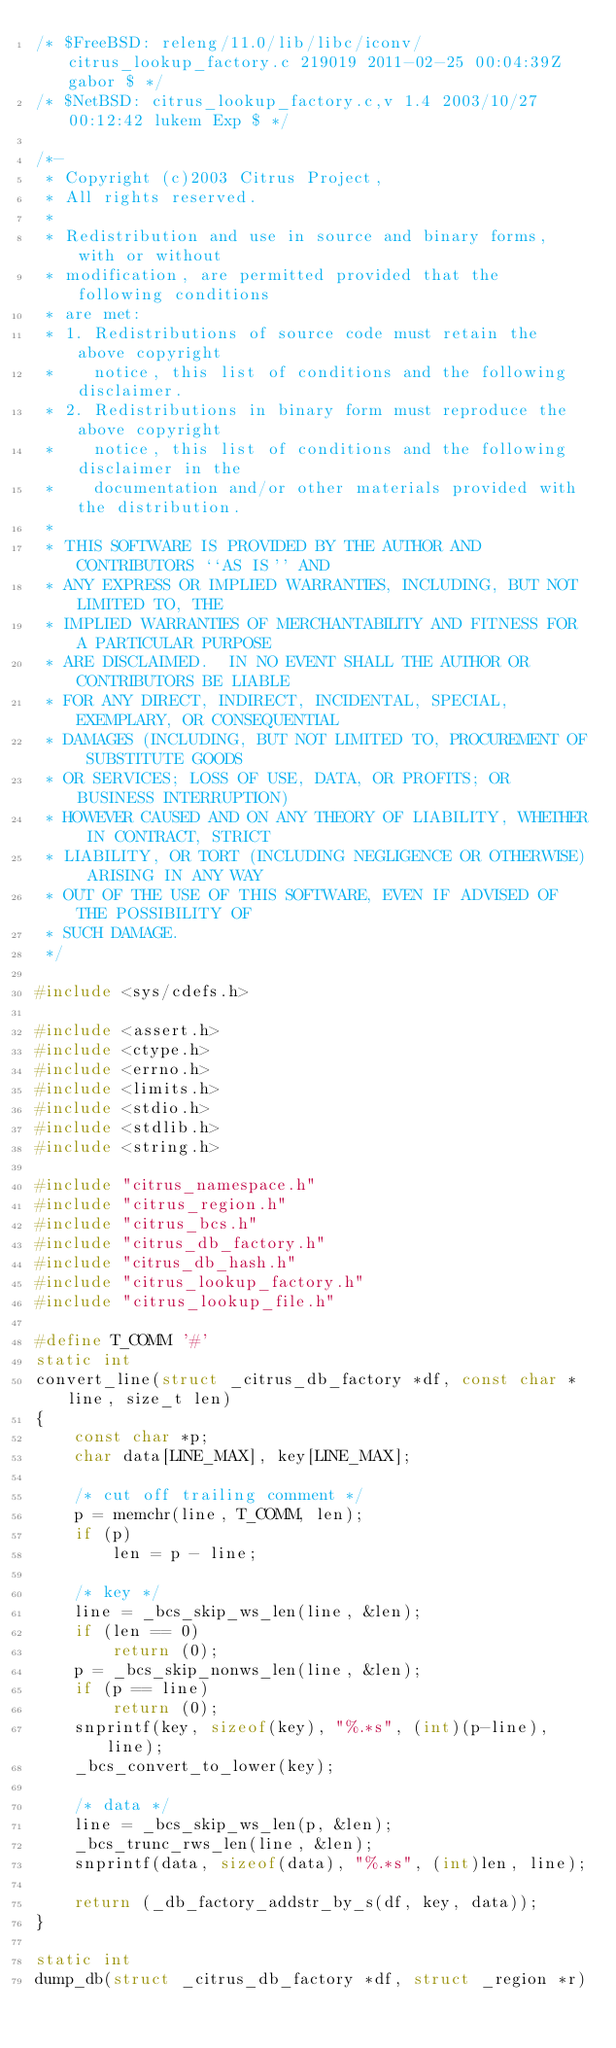Convert code to text. <code><loc_0><loc_0><loc_500><loc_500><_C_>/* $FreeBSD: releng/11.0/lib/libc/iconv/citrus_lookup_factory.c 219019 2011-02-25 00:04:39Z gabor $ */
/* $NetBSD: citrus_lookup_factory.c,v 1.4 2003/10/27 00:12:42 lukem Exp $ */

/*-
 * Copyright (c)2003 Citrus Project,
 * All rights reserved.
 *
 * Redistribution and use in source and binary forms, with or without
 * modification, are permitted provided that the following conditions
 * are met:
 * 1. Redistributions of source code must retain the above copyright
 *    notice, this list of conditions and the following disclaimer.
 * 2. Redistributions in binary form must reproduce the above copyright
 *    notice, this list of conditions and the following disclaimer in the
 *    documentation and/or other materials provided with the distribution.
 *
 * THIS SOFTWARE IS PROVIDED BY THE AUTHOR AND CONTRIBUTORS ``AS IS'' AND
 * ANY EXPRESS OR IMPLIED WARRANTIES, INCLUDING, BUT NOT LIMITED TO, THE
 * IMPLIED WARRANTIES OF MERCHANTABILITY AND FITNESS FOR A PARTICULAR PURPOSE
 * ARE DISCLAIMED.  IN NO EVENT SHALL THE AUTHOR OR CONTRIBUTORS BE LIABLE
 * FOR ANY DIRECT, INDIRECT, INCIDENTAL, SPECIAL, EXEMPLARY, OR CONSEQUENTIAL
 * DAMAGES (INCLUDING, BUT NOT LIMITED TO, PROCUREMENT OF SUBSTITUTE GOODS
 * OR SERVICES; LOSS OF USE, DATA, OR PROFITS; OR BUSINESS INTERRUPTION)
 * HOWEVER CAUSED AND ON ANY THEORY OF LIABILITY, WHETHER IN CONTRACT, STRICT
 * LIABILITY, OR TORT (INCLUDING NEGLIGENCE OR OTHERWISE) ARISING IN ANY WAY
 * OUT OF THE USE OF THIS SOFTWARE, EVEN IF ADVISED OF THE POSSIBILITY OF
 * SUCH DAMAGE.
 */

#include <sys/cdefs.h>

#include <assert.h>
#include <ctype.h>
#include <errno.h>
#include <limits.h>
#include <stdio.h>
#include <stdlib.h>
#include <string.h>

#include "citrus_namespace.h"
#include "citrus_region.h"
#include "citrus_bcs.h"
#include "citrus_db_factory.h"
#include "citrus_db_hash.h"
#include "citrus_lookup_factory.h"
#include "citrus_lookup_file.h"

#define T_COMM '#'
static int
convert_line(struct _citrus_db_factory *df, const char *line, size_t len)
{
	const char *p;
	char data[LINE_MAX], key[LINE_MAX];

	/* cut off trailing comment */
	p = memchr(line, T_COMM, len);
	if (p)
		len = p - line;

	/* key */
	line = _bcs_skip_ws_len(line, &len);
	if (len == 0)
		return (0);
	p = _bcs_skip_nonws_len(line, &len);
	if (p == line)
		return (0);
	snprintf(key, sizeof(key), "%.*s", (int)(p-line), line);
	_bcs_convert_to_lower(key);

	/* data */
	line = _bcs_skip_ws_len(p, &len);
	_bcs_trunc_rws_len(line, &len);
	snprintf(data, sizeof(data), "%.*s", (int)len, line);

	return (_db_factory_addstr_by_s(df, key, data));
}

static int
dump_db(struct _citrus_db_factory *df, struct _region *r)</code> 